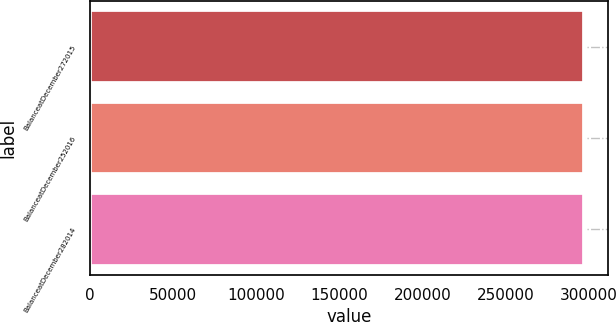Convert chart. <chart><loc_0><loc_0><loc_500><loc_500><bar_chart><fcel>BalanceatDecember272015<fcel>BalanceatDecember252016<fcel>BalanceatDecember282014<nl><fcel>296978<fcel>296978<fcel>296978<nl></chart> 